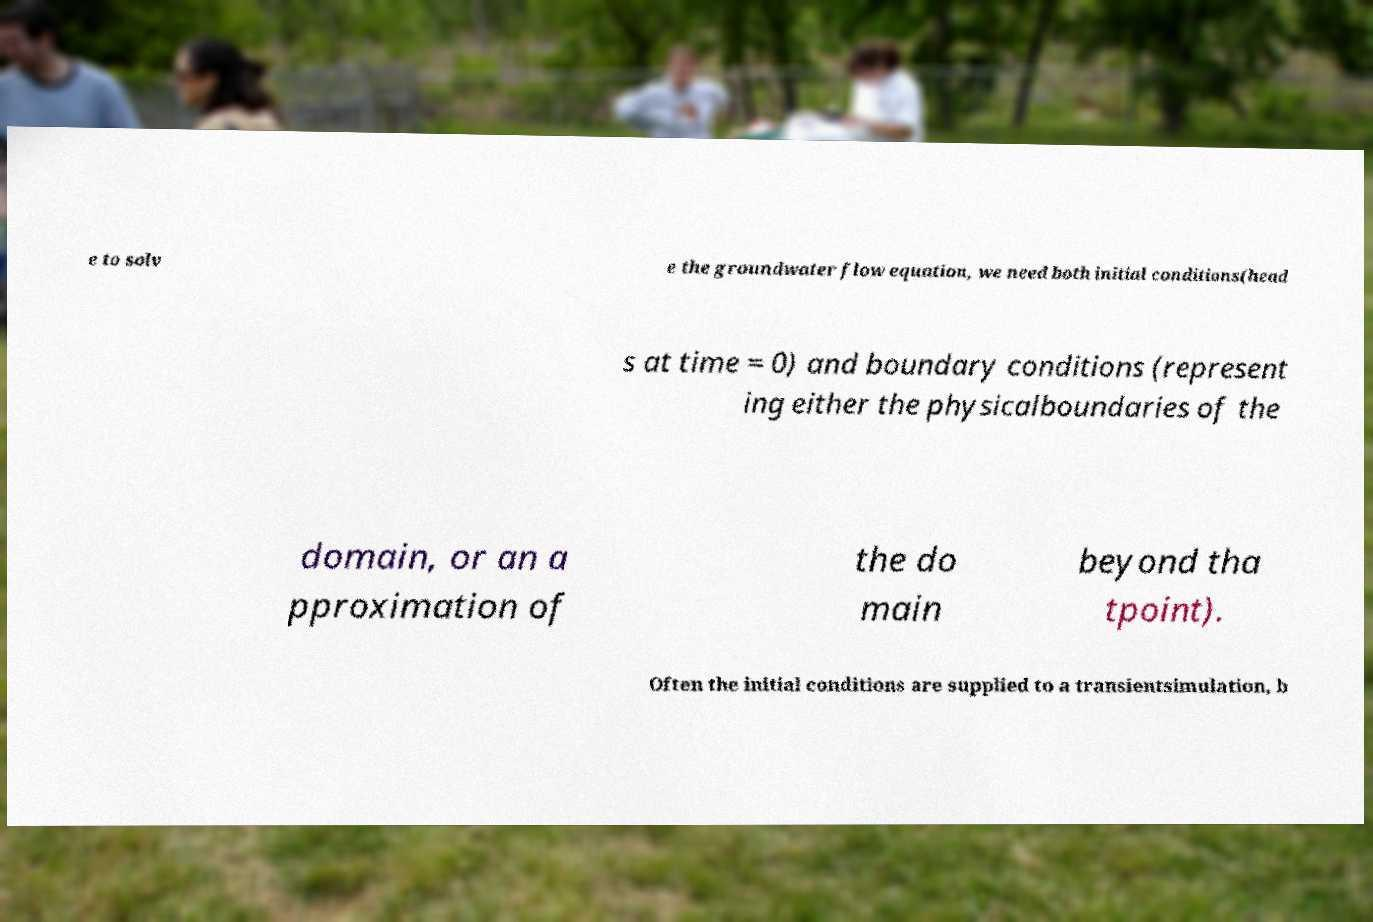I need the written content from this picture converted into text. Can you do that? e to solv e the groundwater flow equation, we need both initial conditions(head s at time = 0) and boundary conditions (represent ing either the physicalboundaries of the domain, or an a pproximation of the do main beyond tha tpoint). Often the initial conditions are supplied to a transientsimulation, b 